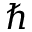Convert formula to latex. <formula><loc_0><loc_0><loc_500><loc_500>\hbar</formula> 